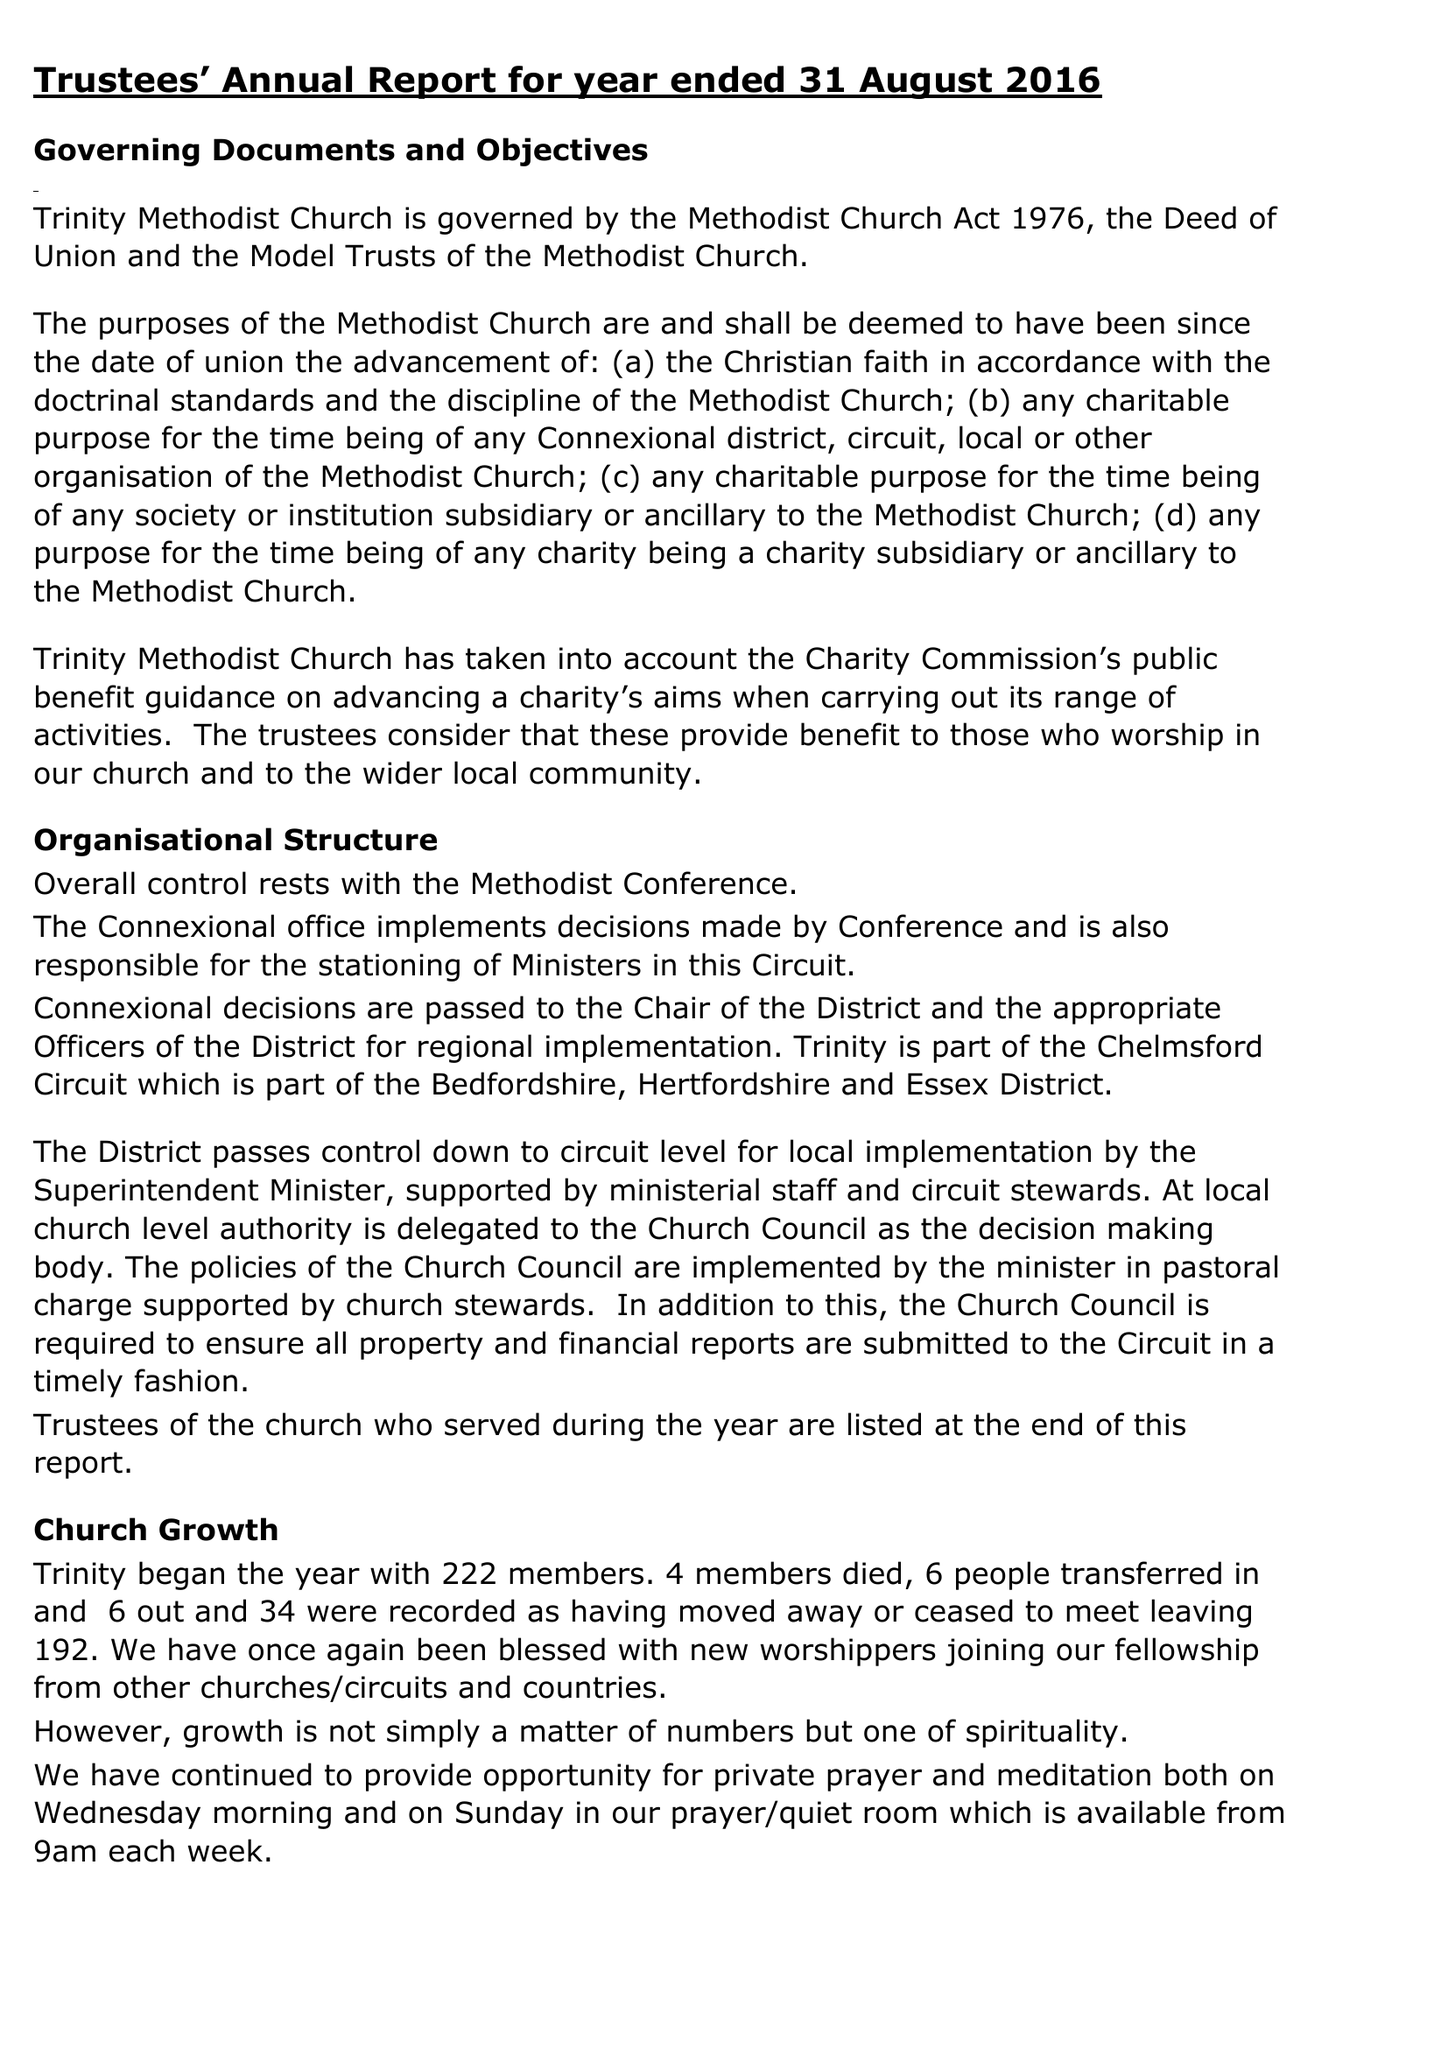What is the value for the income_annually_in_british_pounds?
Answer the question using a single word or phrase. 133929.00 